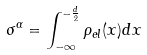<formula> <loc_0><loc_0><loc_500><loc_500>\sigma ^ { \alpha } = \int _ { - \infty } ^ { - \frac { d } { 2 } } \rho _ { e l } ( x ) d { x }</formula> 